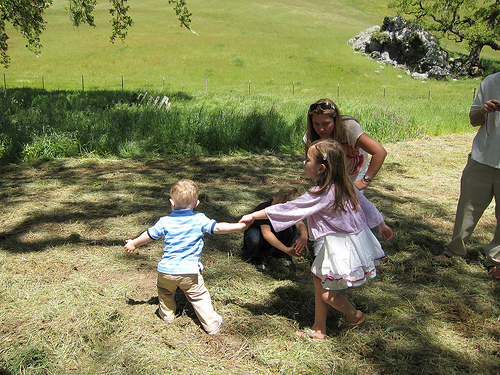<image>
Is the girl to the left of the woman? Yes. From this viewpoint, the girl is positioned to the left side relative to the woman. Where is the grass in relation to the girl? Is it behind the girl? Yes. From this viewpoint, the grass is positioned behind the girl, with the girl partially or fully occluding the grass. Where is the woman in relation to the boy? Is it next to the boy? Yes. The woman is positioned adjacent to the boy, located nearby in the same general area. 